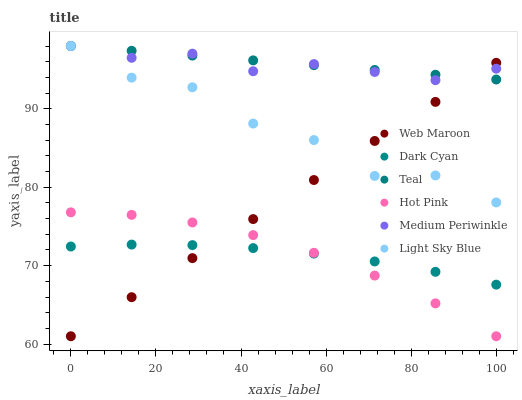Does Dark Cyan have the minimum area under the curve?
Answer yes or no. Yes. Does Teal have the maximum area under the curve?
Answer yes or no. Yes. Does Hot Pink have the minimum area under the curve?
Answer yes or no. No. Does Hot Pink have the maximum area under the curve?
Answer yes or no. No. Is Web Maroon the smoothest?
Answer yes or no. Yes. Is Light Sky Blue the roughest?
Answer yes or no. Yes. Is Hot Pink the smoothest?
Answer yes or no. No. Is Hot Pink the roughest?
Answer yes or no. No. Does Web Maroon have the lowest value?
Answer yes or no. Yes. Does Medium Periwinkle have the lowest value?
Answer yes or no. No. Does Teal have the highest value?
Answer yes or no. Yes. Does Hot Pink have the highest value?
Answer yes or no. No. Is Hot Pink less than Medium Periwinkle?
Answer yes or no. Yes. Is Medium Periwinkle greater than Hot Pink?
Answer yes or no. Yes. Does Light Sky Blue intersect Medium Periwinkle?
Answer yes or no. Yes. Is Light Sky Blue less than Medium Periwinkle?
Answer yes or no. No. Is Light Sky Blue greater than Medium Periwinkle?
Answer yes or no. No. Does Hot Pink intersect Medium Periwinkle?
Answer yes or no. No. 